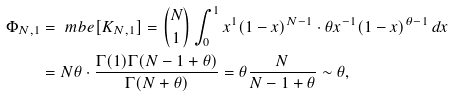<formula> <loc_0><loc_0><loc_500><loc_500>\Phi _ { N , 1 } & = \ m b e [ K _ { N , 1 } ] = \binom { N } { 1 } \int _ { 0 } ^ { 1 } x ^ { 1 } ( 1 - x ) ^ { N - 1 } \cdot \theta x ^ { - 1 } ( 1 - x ) ^ { \theta - 1 } \, d x \\ & = N \theta \cdot \frac { \Gamma ( 1 ) \Gamma ( N - 1 + \theta ) } { \Gamma ( N + \theta ) } = \theta \frac { N } { N - 1 + \theta } \sim \theta ,</formula> 